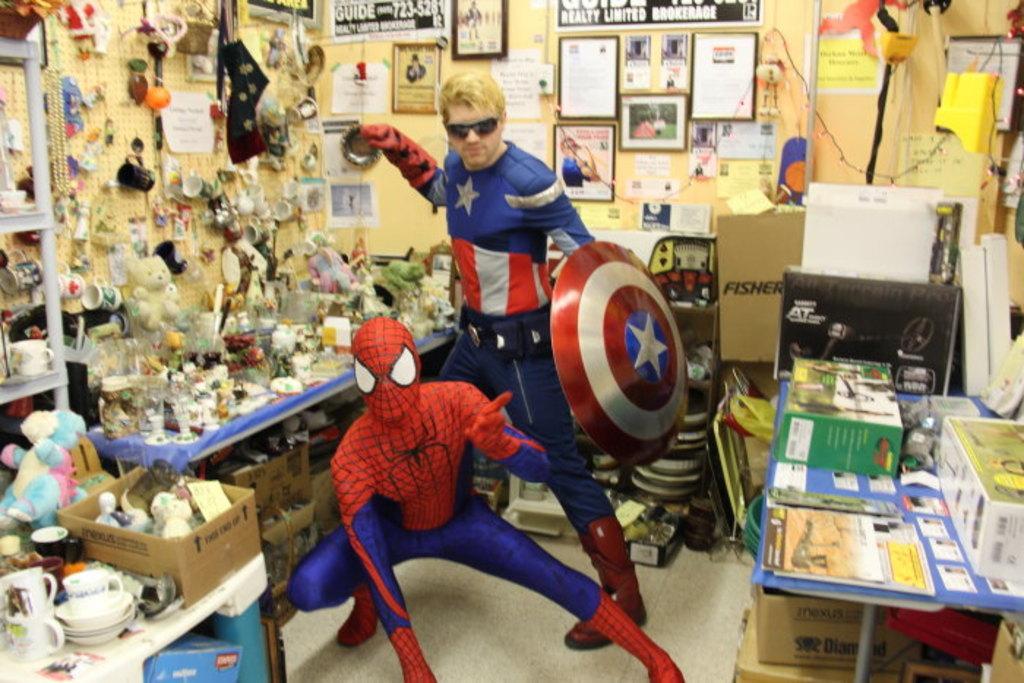In one or two sentences, can you explain what this image depicts? In this picture I can see there are two men standing and they are wearing costumes. There are few objects placed on the right side table and there are carton boxes, other objects, onto left side there are soft toys, key chains, socks and many other objects. In the backdrop there is a wall with photo frames. 